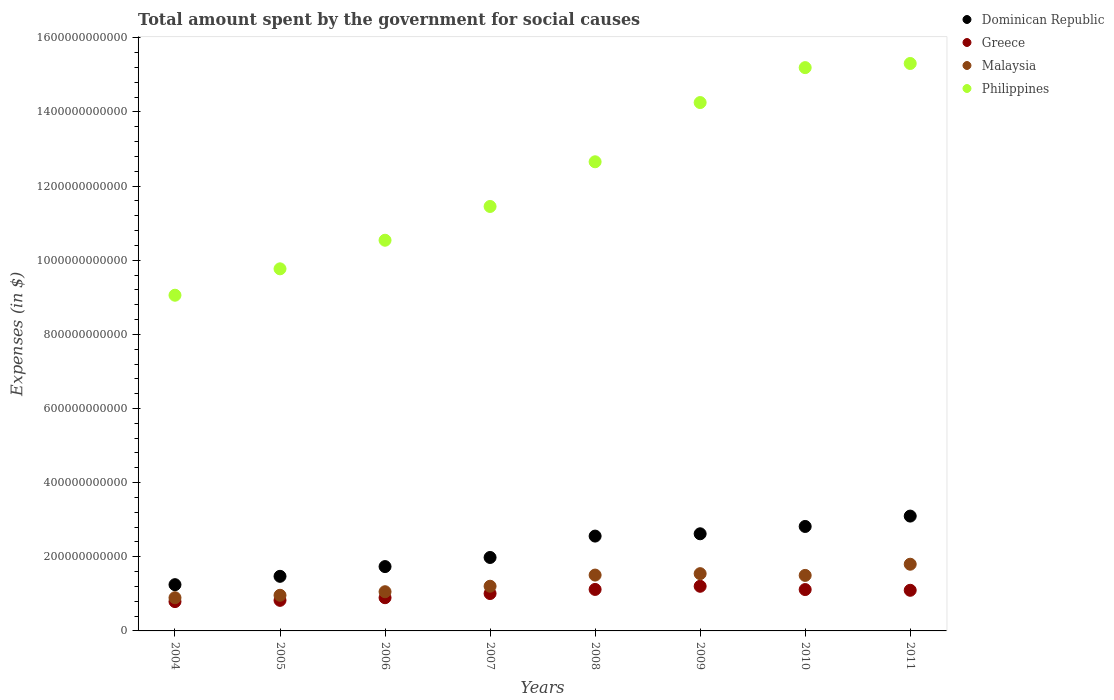How many different coloured dotlines are there?
Your answer should be very brief. 4. Is the number of dotlines equal to the number of legend labels?
Make the answer very short. Yes. What is the amount spent for social causes by the government in Greece in 2007?
Provide a succinct answer. 1.01e+11. Across all years, what is the maximum amount spent for social causes by the government in Philippines?
Keep it short and to the point. 1.53e+12. Across all years, what is the minimum amount spent for social causes by the government in Malaysia?
Keep it short and to the point. 8.95e+1. In which year was the amount spent for social causes by the government in Philippines minimum?
Offer a very short reply. 2004. What is the total amount spent for social causes by the government in Greece in the graph?
Make the answer very short. 8.06e+11. What is the difference between the amount spent for social causes by the government in Dominican Republic in 2005 and that in 2006?
Offer a very short reply. -2.63e+1. What is the difference between the amount spent for social causes by the government in Philippines in 2004 and the amount spent for social causes by the government in Greece in 2005?
Offer a terse response. 8.23e+11. What is the average amount spent for social causes by the government in Greece per year?
Offer a terse response. 1.01e+11. In the year 2010, what is the difference between the amount spent for social causes by the government in Malaysia and amount spent for social causes by the government in Dominican Republic?
Give a very brief answer. -1.32e+11. In how many years, is the amount spent for social causes by the government in Malaysia greater than 80000000000 $?
Your response must be concise. 8. What is the ratio of the amount spent for social causes by the government in Malaysia in 2004 to that in 2011?
Your answer should be compact. 0.5. Is the amount spent for social causes by the government in Malaysia in 2010 less than that in 2011?
Your answer should be compact. Yes. Is the difference between the amount spent for social causes by the government in Malaysia in 2007 and 2008 greater than the difference between the amount spent for social causes by the government in Dominican Republic in 2007 and 2008?
Your answer should be very brief. Yes. What is the difference between the highest and the second highest amount spent for social causes by the government in Greece?
Provide a short and direct response. 8.50e+09. What is the difference between the highest and the lowest amount spent for social causes by the government in Greece?
Provide a succinct answer. 4.13e+1. In how many years, is the amount spent for social causes by the government in Philippines greater than the average amount spent for social causes by the government in Philippines taken over all years?
Offer a very short reply. 4. Is the sum of the amount spent for social causes by the government in Greece in 2008 and 2011 greater than the maximum amount spent for social causes by the government in Dominican Republic across all years?
Give a very brief answer. No. Is the amount spent for social causes by the government in Dominican Republic strictly greater than the amount spent for social causes by the government in Philippines over the years?
Give a very brief answer. No. Is the amount spent for social causes by the government in Greece strictly less than the amount spent for social causes by the government in Philippines over the years?
Provide a succinct answer. Yes. What is the difference between two consecutive major ticks on the Y-axis?
Offer a terse response. 2.00e+11. Are the values on the major ticks of Y-axis written in scientific E-notation?
Give a very brief answer. No. Does the graph contain grids?
Your answer should be compact. No. How are the legend labels stacked?
Keep it short and to the point. Vertical. What is the title of the graph?
Give a very brief answer. Total amount spent by the government for social causes. Does "Montenegro" appear as one of the legend labels in the graph?
Make the answer very short. No. What is the label or title of the X-axis?
Provide a short and direct response. Years. What is the label or title of the Y-axis?
Ensure brevity in your answer.  Expenses (in $). What is the Expenses (in $) in Dominican Republic in 2004?
Your answer should be compact. 1.25e+11. What is the Expenses (in $) of Greece in 2004?
Keep it short and to the point. 7.91e+1. What is the Expenses (in $) of Malaysia in 2004?
Offer a very short reply. 8.95e+1. What is the Expenses (in $) in Philippines in 2004?
Provide a short and direct response. 9.06e+11. What is the Expenses (in $) in Dominican Republic in 2005?
Your answer should be compact. 1.47e+11. What is the Expenses (in $) of Greece in 2005?
Offer a terse response. 8.25e+1. What is the Expenses (in $) in Malaysia in 2005?
Ensure brevity in your answer.  9.61e+1. What is the Expenses (in $) in Philippines in 2005?
Make the answer very short. 9.77e+11. What is the Expenses (in $) of Dominican Republic in 2006?
Your answer should be compact. 1.74e+11. What is the Expenses (in $) of Greece in 2006?
Your answer should be very brief. 8.96e+1. What is the Expenses (in $) of Malaysia in 2006?
Provide a succinct answer. 1.06e+11. What is the Expenses (in $) in Philippines in 2006?
Your response must be concise. 1.05e+12. What is the Expenses (in $) in Dominican Republic in 2007?
Your response must be concise. 1.98e+11. What is the Expenses (in $) in Greece in 2007?
Your response must be concise. 1.01e+11. What is the Expenses (in $) of Malaysia in 2007?
Ensure brevity in your answer.  1.21e+11. What is the Expenses (in $) in Philippines in 2007?
Offer a very short reply. 1.15e+12. What is the Expenses (in $) in Dominican Republic in 2008?
Offer a very short reply. 2.56e+11. What is the Expenses (in $) of Greece in 2008?
Make the answer very short. 1.12e+11. What is the Expenses (in $) in Malaysia in 2008?
Keep it short and to the point. 1.51e+11. What is the Expenses (in $) of Philippines in 2008?
Give a very brief answer. 1.27e+12. What is the Expenses (in $) of Dominican Republic in 2009?
Make the answer very short. 2.62e+11. What is the Expenses (in $) of Greece in 2009?
Provide a succinct answer. 1.20e+11. What is the Expenses (in $) of Malaysia in 2009?
Your response must be concise. 1.54e+11. What is the Expenses (in $) in Philippines in 2009?
Ensure brevity in your answer.  1.43e+12. What is the Expenses (in $) of Dominican Republic in 2010?
Offer a terse response. 2.82e+11. What is the Expenses (in $) of Greece in 2010?
Provide a succinct answer. 1.12e+11. What is the Expenses (in $) of Malaysia in 2010?
Your answer should be very brief. 1.50e+11. What is the Expenses (in $) in Philippines in 2010?
Give a very brief answer. 1.52e+12. What is the Expenses (in $) in Dominican Republic in 2011?
Offer a terse response. 3.10e+11. What is the Expenses (in $) in Greece in 2011?
Offer a terse response. 1.10e+11. What is the Expenses (in $) of Malaysia in 2011?
Your answer should be very brief. 1.80e+11. What is the Expenses (in $) of Philippines in 2011?
Ensure brevity in your answer.  1.53e+12. Across all years, what is the maximum Expenses (in $) in Dominican Republic?
Make the answer very short. 3.10e+11. Across all years, what is the maximum Expenses (in $) in Greece?
Your answer should be very brief. 1.20e+11. Across all years, what is the maximum Expenses (in $) of Malaysia?
Keep it short and to the point. 1.80e+11. Across all years, what is the maximum Expenses (in $) in Philippines?
Your answer should be compact. 1.53e+12. Across all years, what is the minimum Expenses (in $) of Dominican Republic?
Provide a succinct answer. 1.25e+11. Across all years, what is the minimum Expenses (in $) in Greece?
Your answer should be compact. 7.91e+1. Across all years, what is the minimum Expenses (in $) of Malaysia?
Keep it short and to the point. 8.95e+1. Across all years, what is the minimum Expenses (in $) in Philippines?
Ensure brevity in your answer.  9.06e+11. What is the total Expenses (in $) in Dominican Republic in the graph?
Make the answer very short. 1.75e+12. What is the total Expenses (in $) of Greece in the graph?
Your response must be concise. 8.06e+11. What is the total Expenses (in $) of Malaysia in the graph?
Make the answer very short. 1.05e+12. What is the total Expenses (in $) of Philippines in the graph?
Give a very brief answer. 9.82e+12. What is the difference between the Expenses (in $) of Dominican Republic in 2004 and that in 2005?
Give a very brief answer. -2.25e+1. What is the difference between the Expenses (in $) of Greece in 2004 and that in 2005?
Offer a very short reply. -3.38e+09. What is the difference between the Expenses (in $) in Malaysia in 2004 and that in 2005?
Your answer should be compact. -6.61e+09. What is the difference between the Expenses (in $) of Philippines in 2004 and that in 2005?
Keep it short and to the point. -7.12e+1. What is the difference between the Expenses (in $) of Dominican Republic in 2004 and that in 2006?
Offer a terse response. -4.88e+1. What is the difference between the Expenses (in $) in Greece in 2004 and that in 2006?
Give a very brief answer. -1.05e+1. What is the difference between the Expenses (in $) in Malaysia in 2004 and that in 2006?
Make the answer very short. -1.62e+1. What is the difference between the Expenses (in $) in Philippines in 2004 and that in 2006?
Offer a terse response. -1.48e+11. What is the difference between the Expenses (in $) in Dominican Republic in 2004 and that in 2007?
Ensure brevity in your answer.  -7.34e+1. What is the difference between the Expenses (in $) in Greece in 2004 and that in 2007?
Offer a very short reply. -2.17e+1. What is the difference between the Expenses (in $) of Malaysia in 2004 and that in 2007?
Give a very brief answer. -3.10e+1. What is the difference between the Expenses (in $) in Philippines in 2004 and that in 2007?
Your answer should be compact. -2.39e+11. What is the difference between the Expenses (in $) in Dominican Republic in 2004 and that in 2008?
Ensure brevity in your answer.  -1.31e+11. What is the difference between the Expenses (in $) of Greece in 2004 and that in 2008?
Make the answer very short. -3.28e+1. What is the difference between the Expenses (in $) in Malaysia in 2004 and that in 2008?
Provide a short and direct response. -6.11e+1. What is the difference between the Expenses (in $) in Philippines in 2004 and that in 2008?
Give a very brief answer. -3.60e+11. What is the difference between the Expenses (in $) of Dominican Republic in 2004 and that in 2009?
Make the answer very short. -1.37e+11. What is the difference between the Expenses (in $) of Greece in 2004 and that in 2009?
Offer a terse response. -4.13e+1. What is the difference between the Expenses (in $) in Malaysia in 2004 and that in 2009?
Your response must be concise. -6.50e+1. What is the difference between the Expenses (in $) of Philippines in 2004 and that in 2009?
Your answer should be very brief. -5.20e+11. What is the difference between the Expenses (in $) of Dominican Republic in 2004 and that in 2010?
Provide a short and direct response. -1.57e+11. What is the difference between the Expenses (in $) of Greece in 2004 and that in 2010?
Make the answer very short. -3.25e+1. What is the difference between the Expenses (in $) in Malaysia in 2004 and that in 2010?
Keep it short and to the point. -6.02e+1. What is the difference between the Expenses (in $) in Philippines in 2004 and that in 2010?
Give a very brief answer. -6.14e+11. What is the difference between the Expenses (in $) in Dominican Republic in 2004 and that in 2011?
Your response must be concise. -1.85e+11. What is the difference between the Expenses (in $) in Greece in 2004 and that in 2011?
Keep it short and to the point. -3.05e+1. What is the difference between the Expenses (in $) in Malaysia in 2004 and that in 2011?
Your answer should be very brief. -9.04e+1. What is the difference between the Expenses (in $) of Philippines in 2004 and that in 2011?
Ensure brevity in your answer.  -6.25e+11. What is the difference between the Expenses (in $) of Dominican Republic in 2005 and that in 2006?
Provide a short and direct response. -2.63e+1. What is the difference between the Expenses (in $) of Greece in 2005 and that in 2006?
Provide a short and direct response. -7.10e+09. What is the difference between the Expenses (in $) of Malaysia in 2005 and that in 2006?
Make the answer very short. -9.60e+09. What is the difference between the Expenses (in $) of Philippines in 2005 and that in 2006?
Offer a terse response. -7.71e+1. What is the difference between the Expenses (in $) in Dominican Republic in 2005 and that in 2007?
Your response must be concise. -5.08e+1. What is the difference between the Expenses (in $) of Greece in 2005 and that in 2007?
Give a very brief answer. -1.84e+1. What is the difference between the Expenses (in $) in Malaysia in 2005 and that in 2007?
Your answer should be compact. -2.44e+1. What is the difference between the Expenses (in $) in Philippines in 2005 and that in 2007?
Your answer should be compact. -1.68e+11. What is the difference between the Expenses (in $) in Dominican Republic in 2005 and that in 2008?
Ensure brevity in your answer.  -1.09e+11. What is the difference between the Expenses (in $) in Greece in 2005 and that in 2008?
Offer a terse response. -2.95e+1. What is the difference between the Expenses (in $) in Malaysia in 2005 and that in 2008?
Offer a terse response. -5.45e+1. What is the difference between the Expenses (in $) of Philippines in 2005 and that in 2008?
Offer a very short reply. -2.89e+11. What is the difference between the Expenses (in $) of Dominican Republic in 2005 and that in 2009?
Offer a very short reply. -1.15e+11. What is the difference between the Expenses (in $) in Greece in 2005 and that in 2009?
Ensure brevity in your answer.  -3.80e+1. What is the difference between the Expenses (in $) in Malaysia in 2005 and that in 2009?
Offer a very short reply. -5.83e+1. What is the difference between the Expenses (in $) of Philippines in 2005 and that in 2009?
Provide a short and direct response. -4.49e+11. What is the difference between the Expenses (in $) in Dominican Republic in 2005 and that in 2010?
Offer a very short reply. -1.34e+11. What is the difference between the Expenses (in $) in Greece in 2005 and that in 2010?
Your response must be concise. -2.91e+1. What is the difference between the Expenses (in $) in Malaysia in 2005 and that in 2010?
Provide a succinct answer. -5.36e+1. What is the difference between the Expenses (in $) of Philippines in 2005 and that in 2010?
Your answer should be very brief. -5.43e+11. What is the difference between the Expenses (in $) of Dominican Republic in 2005 and that in 2011?
Give a very brief answer. -1.62e+11. What is the difference between the Expenses (in $) of Greece in 2005 and that in 2011?
Give a very brief answer. -2.71e+1. What is the difference between the Expenses (in $) of Malaysia in 2005 and that in 2011?
Your answer should be compact. -8.38e+1. What is the difference between the Expenses (in $) of Philippines in 2005 and that in 2011?
Offer a very short reply. -5.54e+11. What is the difference between the Expenses (in $) of Dominican Republic in 2006 and that in 2007?
Provide a short and direct response. -2.46e+1. What is the difference between the Expenses (in $) in Greece in 2006 and that in 2007?
Provide a succinct answer. -1.13e+1. What is the difference between the Expenses (in $) in Malaysia in 2006 and that in 2007?
Offer a very short reply. -1.48e+1. What is the difference between the Expenses (in $) in Philippines in 2006 and that in 2007?
Give a very brief answer. -9.11e+1. What is the difference between the Expenses (in $) in Dominican Republic in 2006 and that in 2008?
Provide a succinct answer. -8.23e+1. What is the difference between the Expenses (in $) of Greece in 2006 and that in 2008?
Provide a short and direct response. -2.24e+1. What is the difference between the Expenses (in $) of Malaysia in 2006 and that in 2008?
Your answer should be very brief. -4.49e+1. What is the difference between the Expenses (in $) in Philippines in 2006 and that in 2008?
Your response must be concise. -2.12e+11. What is the difference between the Expenses (in $) of Dominican Republic in 2006 and that in 2009?
Your answer should be very brief. -8.85e+1. What is the difference between the Expenses (in $) in Greece in 2006 and that in 2009?
Offer a terse response. -3.09e+1. What is the difference between the Expenses (in $) of Malaysia in 2006 and that in 2009?
Keep it short and to the point. -4.87e+1. What is the difference between the Expenses (in $) in Philippines in 2006 and that in 2009?
Give a very brief answer. -3.71e+11. What is the difference between the Expenses (in $) of Dominican Republic in 2006 and that in 2010?
Keep it short and to the point. -1.08e+11. What is the difference between the Expenses (in $) in Greece in 2006 and that in 2010?
Offer a very short reply. -2.20e+1. What is the difference between the Expenses (in $) of Malaysia in 2006 and that in 2010?
Give a very brief answer. -4.40e+1. What is the difference between the Expenses (in $) in Philippines in 2006 and that in 2010?
Your answer should be compact. -4.66e+11. What is the difference between the Expenses (in $) in Dominican Republic in 2006 and that in 2011?
Your answer should be very brief. -1.36e+11. What is the difference between the Expenses (in $) of Greece in 2006 and that in 2011?
Offer a terse response. -2.00e+1. What is the difference between the Expenses (in $) of Malaysia in 2006 and that in 2011?
Ensure brevity in your answer.  -7.42e+1. What is the difference between the Expenses (in $) in Philippines in 2006 and that in 2011?
Your answer should be very brief. -4.77e+11. What is the difference between the Expenses (in $) of Dominican Republic in 2007 and that in 2008?
Ensure brevity in your answer.  -5.77e+1. What is the difference between the Expenses (in $) in Greece in 2007 and that in 2008?
Keep it short and to the point. -1.11e+1. What is the difference between the Expenses (in $) in Malaysia in 2007 and that in 2008?
Offer a terse response. -3.01e+1. What is the difference between the Expenses (in $) of Philippines in 2007 and that in 2008?
Provide a succinct answer. -1.21e+11. What is the difference between the Expenses (in $) of Dominican Republic in 2007 and that in 2009?
Ensure brevity in your answer.  -6.39e+1. What is the difference between the Expenses (in $) of Greece in 2007 and that in 2009?
Your answer should be compact. -1.96e+1. What is the difference between the Expenses (in $) of Malaysia in 2007 and that in 2009?
Give a very brief answer. -3.39e+1. What is the difference between the Expenses (in $) of Philippines in 2007 and that in 2009?
Offer a very short reply. -2.80e+11. What is the difference between the Expenses (in $) in Dominican Republic in 2007 and that in 2010?
Keep it short and to the point. -8.36e+1. What is the difference between the Expenses (in $) of Greece in 2007 and that in 2010?
Your response must be concise. -1.08e+1. What is the difference between the Expenses (in $) of Malaysia in 2007 and that in 2010?
Your answer should be very brief. -2.92e+1. What is the difference between the Expenses (in $) in Philippines in 2007 and that in 2010?
Your answer should be very brief. -3.75e+11. What is the difference between the Expenses (in $) of Dominican Republic in 2007 and that in 2011?
Your response must be concise. -1.12e+11. What is the difference between the Expenses (in $) of Greece in 2007 and that in 2011?
Offer a terse response. -8.78e+09. What is the difference between the Expenses (in $) of Malaysia in 2007 and that in 2011?
Ensure brevity in your answer.  -5.94e+1. What is the difference between the Expenses (in $) in Philippines in 2007 and that in 2011?
Provide a short and direct response. -3.86e+11. What is the difference between the Expenses (in $) of Dominican Republic in 2008 and that in 2009?
Your answer should be very brief. -6.21e+09. What is the difference between the Expenses (in $) of Greece in 2008 and that in 2009?
Your answer should be compact. -8.50e+09. What is the difference between the Expenses (in $) in Malaysia in 2008 and that in 2009?
Your response must be concise. -3.82e+09. What is the difference between the Expenses (in $) in Philippines in 2008 and that in 2009?
Keep it short and to the point. -1.60e+11. What is the difference between the Expenses (in $) in Dominican Republic in 2008 and that in 2010?
Give a very brief answer. -2.60e+1. What is the difference between the Expenses (in $) in Greece in 2008 and that in 2010?
Provide a short and direct response. 3.37e+08. What is the difference between the Expenses (in $) in Malaysia in 2008 and that in 2010?
Offer a very short reply. 9.00e+08. What is the difference between the Expenses (in $) in Philippines in 2008 and that in 2010?
Your answer should be very brief. -2.54e+11. What is the difference between the Expenses (in $) in Dominican Republic in 2008 and that in 2011?
Offer a very short reply. -5.39e+1. What is the difference between the Expenses (in $) in Greece in 2008 and that in 2011?
Give a very brief answer. 2.32e+09. What is the difference between the Expenses (in $) in Malaysia in 2008 and that in 2011?
Keep it short and to the point. -2.93e+1. What is the difference between the Expenses (in $) of Philippines in 2008 and that in 2011?
Your answer should be very brief. -2.65e+11. What is the difference between the Expenses (in $) of Dominican Republic in 2009 and that in 2010?
Your response must be concise. -1.97e+1. What is the difference between the Expenses (in $) of Greece in 2009 and that in 2010?
Provide a succinct answer. 8.84e+09. What is the difference between the Expenses (in $) in Malaysia in 2009 and that in 2010?
Your answer should be compact. 4.72e+09. What is the difference between the Expenses (in $) in Philippines in 2009 and that in 2010?
Provide a succinct answer. -9.42e+1. What is the difference between the Expenses (in $) in Dominican Republic in 2009 and that in 2011?
Ensure brevity in your answer.  -4.77e+1. What is the difference between the Expenses (in $) of Greece in 2009 and that in 2011?
Your answer should be compact. 1.08e+1. What is the difference between the Expenses (in $) of Malaysia in 2009 and that in 2011?
Provide a succinct answer. -2.54e+1. What is the difference between the Expenses (in $) of Philippines in 2009 and that in 2011?
Your answer should be very brief. -1.05e+11. What is the difference between the Expenses (in $) of Dominican Republic in 2010 and that in 2011?
Your response must be concise. -2.80e+1. What is the difference between the Expenses (in $) in Greece in 2010 and that in 2011?
Offer a terse response. 1.98e+09. What is the difference between the Expenses (in $) of Malaysia in 2010 and that in 2011?
Make the answer very short. -3.02e+1. What is the difference between the Expenses (in $) of Philippines in 2010 and that in 2011?
Your answer should be very brief. -1.12e+1. What is the difference between the Expenses (in $) of Dominican Republic in 2004 and the Expenses (in $) of Greece in 2005?
Your response must be concise. 4.23e+1. What is the difference between the Expenses (in $) of Dominican Republic in 2004 and the Expenses (in $) of Malaysia in 2005?
Ensure brevity in your answer.  2.86e+1. What is the difference between the Expenses (in $) in Dominican Republic in 2004 and the Expenses (in $) in Philippines in 2005?
Provide a succinct answer. -8.52e+11. What is the difference between the Expenses (in $) of Greece in 2004 and the Expenses (in $) of Malaysia in 2005?
Ensure brevity in your answer.  -1.70e+1. What is the difference between the Expenses (in $) of Greece in 2004 and the Expenses (in $) of Philippines in 2005?
Your response must be concise. -8.98e+11. What is the difference between the Expenses (in $) in Malaysia in 2004 and the Expenses (in $) in Philippines in 2005?
Your answer should be compact. -8.87e+11. What is the difference between the Expenses (in $) in Dominican Republic in 2004 and the Expenses (in $) in Greece in 2006?
Your response must be concise. 3.52e+1. What is the difference between the Expenses (in $) of Dominican Republic in 2004 and the Expenses (in $) of Malaysia in 2006?
Provide a short and direct response. 1.90e+1. What is the difference between the Expenses (in $) in Dominican Republic in 2004 and the Expenses (in $) in Philippines in 2006?
Your answer should be compact. -9.29e+11. What is the difference between the Expenses (in $) of Greece in 2004 and the Expenses (in $) of Malaysia in 2006?
Offer a terse response. -2.67e+1. What is the difference between the Expenses (in $) in Greece in 2004 and the Expenses (in $) in Philippines in 2006?
Offer a terse response. -9.75e+11. What is the difference between the Expenses (in $) in Malaysia in 2004 and the Expenses (in $) in Philippines in 2006?
Your response must be concise. -9.64e+11. What is the difference between the Expenses (in $) in Dominican Republic in 2004 and the Expenses (in $) in Greece in 2007?
Give a very brief answer. 2.39e+1. What is the difference between the Expenses (in $) in Dominican Republic in 2004 and the Expenses (in $) in Malaysia in 2007?
Your response must be concise. 4.23e+09. What is the difference between the Expenses (in $) in Dominican Republic in 2004 and the Expenses (in $) in Philippines in 2007?
Your answer should be very brief. -1.02e+12. What is the difference between the Expenses (in $) in Greece in 2004 and the Expenses (in $) in Malaysia in 2007?
Offer a very short reply. -4.15e+1. What is the difference between the Expenses (in $) of Greece in 2004 and the Expenses (in $) of Philippines in 2007?
Give a very brief answer. -1.07e+12. What is the difference between the Expenses (in $) of Malaysia in 2004 and the Expenses (in $) of Philippines in 2007?
Your response must be concise. -1.06e+12. What is the difference between the Expenses (in $) of Dominican Republic in 2004 and the Expenses (in $) of Greece in 2008?
Offer a very short reply. 1.29e+1. What is the difference between the Expenses (in $) in Dominican Republic in 2004 and the Expenses (in $) in Malaysia in 2008?
Provide a short and direct response. -2.59e+1. What is the difference between the Expenses (in $) of Dominican Republic in 2004 and the Expenses (in $) of Philippines in 2008?
Your response must be concise. -1.14e+12. What is the difference between the Expenses (in $) of Greece in 2004 and the Expenses (in $) of Malaysia in 2008?
Your answer should be compact. -7.16e+1. What is the difference between the Expenses (in $) of Greece in 2004 and the Expenses (in $) of Philippines in 2008?
Your response must be concise. -1.19e+12. What is the difference between the Expenses (in $) of Malaysia in 2004 and the Expenses (in $) of Philippines in 2008?
Give a very brief answer. -1.18e+12. What is the difference between the Expenses (in $) of Dominican Republic in 2004 and the Expenses (in $) of Greece in 2009?
Your answer should be very brief. 4.35e+09. What is the difference between the Expenses (in $) of Dominican Republic in 2004 and the Expenses (in $) of Malaysia in 2009?
Give a very brief answer. -2.97e+1. What is the difference between the Expenses (in $) in Dominican Republic in 2004 and the Expenses (in $) in Philippines in 2009?
Provide a succinct answer. -1.30e+12. What is the difference between the Expenses (in $) in Greece in 2004 and the Expenses (in $) in Malaysia in 2009?
Your answer should be very brief. -7.54e+1. What is the difference between the Expenses (in $) of Greece in 2004 and the Expenses (in $) of Philippines in 2009?
Give a very brief answer. -1.35e+12. What is the difference between the Expenses (in $) in Malaysia in 2004 and the Expenses (in $) in Philippines in 2009?
Ensure brevity in your answer.  -1.34e+12. What is the difference between the Expenses (in $) of Dominican Republic in 2004 and the Expenses (in $) of Greece in 2010?
Offer a terse response. 1.32e+1. What is the difference between the Expenses (in $) in Dominican Republic in 2004 and the Expenses (in $) in Malaysia in 2010?
Offer a very short reply. -2.50e+1. What is the difference between the Expenses (in $) of Dominican Republic in 2004 and the Expenses (in $) of Philippines in 2010?
Make the answer very short. -1.39e+12. What is the difference between the Expenses (in $) of Greece in 2004 and the Expenses (in $) of Malaysia in 2010?
Ensure brevity in your answer.  -7.07e+1. What is the difference between the Expenses (in $) of Greece in 2004 and the Expenses (in $) of Philippines in 2010?
Give a very brief answer. -1.44e+12. What is the difference between the Expenses (in $) in Malaysia in 2004 and the Expenses (in $) in Philippines in 2010?
Make the answer very short. -1.43e+12. What is the difference between the Expenses (in $) of Dominican Republic in 2004 and the Expenses (in $) of Greece in 2011?
Ensure brevity in your answer.  1.52e+1. What is the difference between the Expenses (in $) of Dominican Republic in 2004 and the Expenses (in $) of Malaysia in 2011?
Your answer should be compact. -5.51e+1. What is the difference between the Expenses (in $) of Dominican Republic in 2004 and the Expenses (in $) of Philippines in 2011?
Give a very brief answer. -1.41e+12. What is the difference between the Expenses (in $) of Greece in 2004 and the Expenses (in $) of Malaysia in 2011?
Offer a terse response. -1.01e+11. What is the difference between the Expenses (in $) of Greece in 2004 and the Expenses (in $) of Philippines in 2011?
Ensure brevity in your answer.  -1.45e+12. What is the difference between the Expenses (in $) in Malaysia in 2004 and the Expenses (in $) in Philippines in 2011?
Offer a very short reply. -1.44e+12. What is the difference between the Expenses (in $) of Dominican Republic in 2005 and the Expenses (in $) of Greece in 2006?
Your answer should be very brief. 5.77e+1. What is the difference between the Expenses (in $) of Dominican Republic in 2005 and the Expenses (in $) of Malaysia in 2006?
Make the answer very short. 4.16e+1. What is the difference between the Expenses (in $) of Dominican Republic in 2005 and the Expenses (in $) of Philippines in 2006?
Provide a short and direct response. -9.07e+11. What is the difference between the Expenses (in $) in Greece in 2005 and the Expenses (in $) in Malaysia in 2006?
Your answer should be compact. -2.33e+1. What is the difference between the Expenses (in $) of Greece in 2005 and the Expenses (in $) of Philippines in 2006?
Ensure brevity in your answer.  -9.71e+11. What is the difference between the Expenses (in $) in Malaysia in 2005 and the Expenses (in $) in Philippines in 2006?
Offer a terse response. -9.58e+11. What is the difference between the Expenses (in $) of Dominican Republic in 2005 and the Expenses (in $) of Greece in 2007?
Your answer should be very brief. 4.65e+1. What is the difference between the Expenses (in $) in Dominican Republic in 2005 and the Expenses (in $) in Malaysia in 2007?
Make the answer very short. 2.67e+1. What is the difference between the Expenses (in $) in Dominican Republic in 2005 and the Expenses (in $) in Philippines in 2007?
Give a very brief answer. -9.98e+11. What is the difference between the Expenses (in $) of Greece in 2005 and the Expenses (in $) of Malaysia in 2007?
Ensure brevity in your answer.  -3.81e+1. What is the difference between the Expenses (in $) of Greece in 2005 and the Expenses (in $) of Philippines in 2007?
Your answer should be very brief. -1.06e+12. What is the difference between the Expenses (in $) of Malaysia in 2005 and the Expenses (in $) of Philippines in 2007?
Ensure brevity in your answer.  -1.05e+12. What is the difference between the Expenses (in $) of Dominican Republic in 2005 and the Expenses (in $) of Greece in 2008?
Ensure brevity in your answer.  3.54e+1. What is the difference between the Expenses (in $) in Dominican Republic in 2005 and the Expenses (in $) in Malaysia in 2008?
Provide a short and direct response. -3.37e+09. What is the difference between the Expenses (in $) in Dominican Republic in 2005 and the Expenses (in $) in Philippines in 2008?
Provide a succinct answer. -1.12e+12. What is the difference between the Expenses (in $) of Greece in 2005 and the Expenses (in $) of Malaysia in 2008?
Keep it short and to the point. -6.82e+1. What is the difference between the Expenses (in $) of Greece in 2005 and the Expenses (in $) of Philippines in 2008?
Offer a terse response. -1.18e+12. What is the difference between the Expenses (in $) in Malaysia in 2005 and the Expenses (in $) in Philippines in 2008?
Offer a terse response. -1.17e+12. What is the difference between the Expenses (in $) of Dominican Republic in 2005 and the Expenses (in $) of Greece in 2009?
Keep it short and to the point. 2.69e+1. What is the difference between the Expenses (in $) of Dominican Republic in 2005 and the Expenses (in $) of Malaysia in 2009?
Offer a terse response. -7.19e+09. What is the difference between the Expenses (in $) of Dominican Republic in 2005 and the Expenses (in $) of Philippines in 2009?
Your answer should be compact. -1.28e+12. What is the difference between the Expenses (in $) in Greece in 2005 and the Expenses (in $) in Malaysia in 2009?
Offer a terse response. -7.20e+1. What is the difference between the Expenses (in $) in Greece in 2005 and the Expenses (in $) in Philippines in 2009?
Provide a short and direct response. -1.34e+12. What is the difference between the Expenses (in $) of Malaysia in 2005 and the Expenses (in $) of Philippines in 2009?
Ensure brevity in your answer.  -1.33e+12. What is the difference between the Expenses (in $) in Dominican Republic in 2005 and the Expenses (in $) in Greece in 2010?
Your answer should be very brief. 3.57e+1. What is the difference between the Expenses (in $) in Dominican Republic in 2005 and the Expenses (in $) in Malaysia in 2010?
Your response must be concise. -2.46e+09. What is the difference between the Expenses (in $) of Dominican Republic in 2005 and the Expenses (in $) of Philippines in 2010?
Your answer should be very brief. -1.37e+12. What is the difference between the Expenses (in $) of Greece in 2005 and the Expenses (in $) of Malaysia in 2010?
Ensure brevity in your answer.  -6.73e+1. What is the difference between the Expenses (in $) in Greece in 2005 and the Expenses (in $) in Philippines in 2010?
Offer a terse response. -1.44e+12. What is the difference between the Expenses (in $) of Malaysia in 2005 and the Expenses (in $) of Philippines in 2010?
Provide a succinct answer. -1.42e+12. What is the difference between the Expenses (in $) in Dominican Republic in 2005 and the Expenses (in $) in Greece in 2011?
Keep it short and to the point. 3.77e+1. What is the difference between the Expenses (in $) of Dominican Republic in 2005 and the Expenses (in $) of Malaysia in 2011?
Provide a short and direct response. -3.26e+1. What is the difference between the Expenses (in $) in Dominican Republic in 2005 and the Expenses (in $) in Philippines in 2011?
Your response must be concise. -1.38e+12. What is the difference between the Expenses (in $) of Greece in 2005 and the Expenses (in $) of Malaysia in 2011?
Your response must be concise. -9.75e+1. What is the difference between the Expenses (in $) in Greece in 2005 and the Expenses (in $) in Philippines in 2011?
Make the answer very short. -1.45e+12. What is the difference between the Expenses (in $) of Malaysia in 2005 and the Expenses (in $) of Philippines in 2011?
Ensure brevity in your answer.  -1.43e+12. What is the difference between the Expenses (in $) of Dominican Republic in 2006 and the Expenses (in $) of Greece in 2007?
Your response must be concise. 7.27e+1. What is the difference between the Expenses (in $) in Dominican Republic in 2006 and the Expenses (in $) in Malaysia in 2007?
Keep it short and to the point. 5.30e+1. What is the difference between the Expenses (in $) of Dominican Republic in 2006 and the Expenses (in $) of Philippines in 2007?
Ensure brevity in your answer.  -9.71e+11. What is the difference between the Expenses (in $) of Greece in 2006 and the Expenses (in $) of Malaysia in 2007?
Provide a short and direct response. -3.10e+1. What is the difference between the Expenses (in $) of Greece in 2006 and the Expenses (in $) of Philippines in 2007?
Make the answer very short. -1.06e+12. What is the difference between the Expenses (in $) of Malaysia in 2006 and the Expenses (in $) of Philippines in 2007?
Offer a very short reply. -1.04e+12. What is the difference between the Expenses (in $) of Dominican Republic in 2006 and the Expenses (in $) of Greece in 2008?
Keep it short and to the point. 6.16e+1. What is the difference between the Expenses (in $) of Dominican Republic in 2006 and the Expenses (in $) of Malaysia in 2008?
Your response must be concise. 2.29e+1. What is the difference between the Expenses (in $) in Dominican Republic in 2006 and the Expenses (in $) in Philippines in 2008?
Your answer should be compact. -1.09e+12. What is the difference between the Expenses (in $) of Greece in 2006 and the Expenses (in $) of Malaysia in 2008?
Ensure brevity in your answer.  -6.11e+1. What is the difference between the Expenses (in $) in Greece in 2006 and the Expenses (in $) in Philippines in 2008?
Offer a terse response. -1.18e+12. What is the difference between the Expenses (in $) in Malaysia in 2006 and the Expenses (in $) in Philippines in 2008?
Your response must be concise. -1.16e+12. What is the difference between the Expenses (in $) of Dominican Republic in 2006 and the Expenses (in $) of Greece in 2009?
Keep it short and to the point. 5.31e+1. What is the difference between the Expenses (in $) of Dominican Republic in 2006 and the Expenses (in $) of Malaysia in 2009?
Offer a terse response. 1.91e+1. What is the difference between the Expenses (in $) of Dominican Republic in 2006 and the Expenses (in $) of Philippines in 2009?
Offer a terse response. -1.25e+12. What is the difference between the Expenses (in $) of Greece in 2006 and the Expenses (in $) of Malaysia in 2009?
Ensure brevity in your answer.  -6.49e+1. What is the difference between the Expenses (in $) in Greece in 2006 and the Expenses (in $) in Philippines in 2009?
Provide a succinct answer. -1.34e+12. What is the difference between the Expenses (in $) of Malaysia in 2006 and the Expenses (in $) of Philippines in 2009?
Make the answer very short. -1.32e+12. What is the difference between the Expenses (in $) in Dominican Republic in 2006 and the Expenses (in $) in Greece in 2010?
Your answer should be very brief. 6.20e+1. What is the difference between the Expenses (in $) in Dominican Republic in 2006 and the Expenses (in $) in Malaysia in 2010?
Your answer should be very brief. 2.38e+1. What is the difference between the Expenses (in $) in Dominican Republic in 2006 and the Expenses (in $) in Philippines in 2010?
Provide a short and direct response. -1.35e+12. What is the difference between the Expenses (in $) in Greece in 2006 and the Expenses (in $) in Malaysia in 2010?
Keep it short and to the point. -6.02e+1. What is the difference between the Expenses (in $) of Greece in 2006 and the Expenses (in $) of Philippines in 2010?
Keep it short and to the point. -1.43e+12. What is the difference between the Expenses (in $) of Malaysia in 2006 and the Expenses (in $) of Philippines in 2010?
Make the answer very short. -1.41e+12. What is the difference between the Expenses (in $) in Dominican Republic in 2006 and the Expenses (in $) in Greece in 2011?
Your answer should be very brief. 6.40e+1. What is the difference between the Expenses (in $) in Dominican Republic in 2006 and the Expenses (in $) in Malaysia in 2011?
Ensure brevity in your answer.  -6.36e+09. What is the difference between the Expenses (in $) of Dominican Republic in 2006 and the Expenses (in $) of Philippines in 2011?
Make the answer very short. -1.36e+12. What is the difference between the Expenses (in $) of Greece in 2006 and the Expenses (in $) of Malaysia in 2011?
Your answer should be compact. -9.04e+1. What is the difference between the Expenses (in $) of Greece in 2006 and the Expenses (in $) of Philippines in 2011?
Provide a succinct answer. -1.44e+12. What is the difference between the Expenses (in $) in Malaysia in 2006 and the Expenses (in $) in Philippines in 2011?
Provide a succinct answer. -1.43e+12. What is the difference between the Expenses (in $) of Dominican Republic in 2007 and the Expenses (in $) of Greece in 2008?
Offer a very short reply. 8.62e+1. What is the difference between the Expenses (in $) in Dominican Republic in 2007 and the Expenses (in $) in Malaysia in 2008?
Your answer should be very brief. 4.75e+1. What is the difference between the Expenses (in $) of Dominican Republic in 2007 and the Expenses (in $) of Philippines in 2008?
Keep it short and to the point. -1.07e+12. What is the difference between the Expenses (in $) of Greece in 2007 and the Expenses (in $) of Malaysia in 2008?
Make the answer very short. -4.98e+1. What is the difference between the Expenses (in $) in Greece in 2007 and the Expenses (in $) in Philippines in 2008?
Offer a terse response. -1.16e+12. What is the difference between the Expenses (in $) in Malaysia in 2007 and the Expenses (in $) in Philippines in 2008?
Your answer should be very brief. -1.15e+12. What is the difference between the Expenses (in $) in Dominican Republic in 2007 and the Expenses (in $) in Greece in 2009?
Offer a very short reply. 7.77e+1. What is the difference between the Expenses (in $) in Dominican Republic in 2007 and the Expenses (in $) in Malaysia in 2009?
Offer a terse response. 4.37e+1. What is the difference between the Expenses (in $) in Dominican Republic in 2007 and the Expenses (in $) in Philippines in 2009?
Give a very brief answer. -1.23e+12. What is the difference between the Expenses (in $) in Greece in 2007 and the Expenses (in $) in Malaysia in 2009?
Make the answer very short. -5.37e+1. What is the difference between the Expenses (in $) of Greece in 2007 and the Expenses (in $) of Philippines in 2009?
Make the answer very short. -1.32e+12. What is the difference between the Expenses (in $) in Malaysia in 2007 and the Expenses (in $) in Philippines in 2009?
Your response must be concise. -1.30e+12. What is the difference between the Expenses (in $) in Dominican Republic in 2007 and the Expenses (in $) in Greece in 2010?
Your answer should be very brief. 8.65e+1. What is the difference between the Expenses (in $) of Dominican Republic in 2007 and the Expenses (in $) of Malaysia in 2010?
Your answer should be very brief. 4.84e+1. What is the difference between the Expenses (in $) in Dominican Republic in 2007 and the Expenses (in $) in Philippines in 2010?
Your answer should be very brief. -1.32e+12. What is the difference between the Expenses (in $) of Greece in 2007 and the Expenses (in $) of Malaysia in 2010?
Offer a terse response. -4.89e+1. What is the difference between the Expenses (in $) in Greece in 2007 and the Expenses (in $) in Philippines in 2010?
Your answer should be very brief. -1.42e+12. What is the difference between the Expenses (in $) of Malaysia in 2007 and the Expenses (in $) of Philippines in 2010?
Your answer should be compact. -1.40e+12. What is the difference between the Expenses (in $) in Dominican Republic in 2007 and the Expenses (in $) in Greece in 2011?
Your answer should be very brief. 8.85e+1. What is the difference between the Expenses (in $) of Dominican Republic in 2007 and the Expenses (in $) of Malaysia in 2011?
Provide a short and direct response. 1.82e+1. What is the difference between the Expenses (in $) of Dominican Republic in 2007 and the Expenses (in $) of Philippines in 2011?
Provide a succinct answer. -1.33e+12. What is the difference between the Expenses (in $) of Greece in 2007 and the Expenses (in $) of Malaysia in 2011?
Provide a short and direct response. -7.91e+1. What is the difference between the Expenses (in $) of Greece in 2007 and the Expenses (in $) of Philippines in 2011?
Offer a terse response. -1.43e+12. What is the difference between the Expenses (in $) in Malaysia in 2007 and the Expenses (in $) in Philippines in 2011?
Keep it short and to the point. -1.41e+12. What is the difference between the Expenses (in $) in Dominican Republic in 2008 and the Expenses (in $) in Greece in 2009?
Keep it short and to the point. 1.35e+11. What is the difference between the Expenses (in $) in Dominican Republic in 2008 and the Expenses (in $) in Malaysia in 2009?
Your response must be concise. 1.01e+11. What is the difference between the Expenses (in $) of Dominican Republic in 2008 and the Expenses (in $) of Philippines in 2009?
Offer a terse response. -1.17e+12. What is the difference between the Expenses (in $) of Greece in 2008 and the Expenses (in $) of Malaysia in 2009?
Your answer should be compact. -4.26e+1. What is the difference between the Expenses (in $) in Greece in 2008 and the Expenses (in $) in Philippines in 2009?
Give a very brief answer. -1.31e+12. What is the difference between the Expenses (in $) of Malaysia in 2008 and the Expenses (in $) of Philippines in 2009?
Your answer should be very brief. -1.27e+12. What is the difference between the Expenses (in $) of Dominican Republic in 2008 and the Expenses (in $) of Greece in 2010?
Offer a very short reply. 1.44e+11. What is the difference between the Expenses (in $) of Dominican Republic in 2008 and the Expenses (in $) of Malaysia in 2010?
Your answer should be very brief. 1.06e+11. What is the difference between the Expenses (in $) of Dominican Republic in 2008 and the Expenses (in $) of Philippines in 2010?
Offer a terse response. -1.26e+12. What is the difference between the Expenses (in $) in Greece in 2008 and the Expenses (in $) in Malaysia in 2010?
Ensure brevity in your answer.  -3.78e+1. What is the difference between the Expenses (in $) in Greece in 2008 and the Expenses (in $) in Philippines in 2010?
Provide a succinct answer. -1.41e+12. What is the difference between the Expenses (in $) of Malaysia in 2008 and the Expenses (in $) of Philippines in 2010?
Your response must be concise. -1.37e+12. What is the difference between the Expenses (in $) of Dominican Republic in 2008 and the Expenses (in $) of Greece in 2011?
Offer a terse response. 1.46e+11. What is the difference between the Expenses (in $) of Dominican Republic in 2008 and the Expenses (in $) of Malaysia in 2011?
Offer a very short reply. 7.59e+1. What is the difference between the Expenses (in $) in Dominican Republic in 2008 and the Expenses (in $) in Philippines in 2011?
Your response must be concise. -1.27e+12. What is the difference between the Expenses (in $) of Greece in 2008 and the Expenses (in $) of Malaysia in 2011?
Give a very brief answer. -6.80e+1. What is the difference between the Expenses (in $) of Greece in 2008 and the Expenses (in $) of Philippines in 2011?
Your response must be concise. -1.42e+12. What is the difference between the Expenses (in $) of Malaysia in 2008 and the Expenses (in $) of Philippines in 2011?
Keep it short and to the point. -1.38e+12. What is the difference between the Expenses (in $) of Dominican Republic in 2009 and the Expenses (in $) of Greece in 2010?
Give a very brief answer. 1.50e+11. What is the difference between the Expenses (in $) of Dominican Republic in 2009 and the Expenses (in $) of Malaysia in 2010?
Offer a very short reply. 1.12e+11. What is the difference between the Expenses (in $) of Dominican Republic in 2009 and the Expenses (in $) of Philippines in 2010?
Your answer should be very brief. -1.26e+12. What is the difference between the Expenses (in $) in Greece in 2009 and the Expenses (in $) in Malaysia in 2010?
Your response must be concise. -2.93e+1. What is the difference between the Expenses (in $) of Greece in 2009 and the Expenses (in $) of Philippines in 2010?
Offer a terse response. -1.40e+12. What is the difference between the Expenses (in $) of Malaysia in 2009 and the Expenses (in $) of Philippines in 2010?
Your answer should be compact. -1.37e+12. What is the difference between the Expenses (in $) of Dominican Republic in 2009 and the Expenses (in $) of Greece in 2011?
Provide a succinct answer. 1.52e+11. What is the difference between the Expenses (in $) of Dominican Republic in 2009 and the Expenses (in $) of Malaysia in 2011?
Ensure brevity in your answer.  8.21e+1. What is the difference between the Expenses (in $) in Dominican Republic in 2009 and the Expenses (in $) in Philippines in 2011?
Provide a succinct answer. -1.27e+12. What is the difference between the Expenses (in $) of Greece in 2009 and the Expenses (in $) of Malaysia in 2011?
Offer a terse response. -5.95e+1. What is the difference between the Expenses (in $) in Greece in 2009 and the Expenses (in $) in Philippines in 2011?
Ensure brevity in your answer.  -1.41e+12. What is the difference between the Expenses (in $) of Malaysia in 2009 and the Expenses (in $) of Philippines in 2011?
Provide a succinct answer. -1.38e+12. What is the difference between the Expenses (in $) of Dominican Republic in 2010 and the Expenses (in $) of Greece in 2011?
Keep it short and to the point. 1.72e+11. What is the difference between the Expenses (in $) of Dominican Republic in 2010 and the Expenses (in $) of Malaysia in 2011?
Offer a terse response. 1.02e+11. What is the difference between the Expenses (in $) of Dominican Republic in 2010 and the Expenses (in $) of Philippines in 2011?
Keep it short and to the point. -1.25e+12. What is the difference between the Expenses (in $) of Greece in 2010 and the Expenses (in $) of Malaysia in 2011?
Your answer should be very brief. -6.83e+1. What is the difference between the Expenses (in $) of Greece in 2010 and the Expenses (in $) of Philippines in 2011?
Your answer should be compact. -1.42e+12. What is the difference between the Expenses (in $) in Malaysia in 2010 and the Expenses (in $) in Philippines in 2011?
Your response must be concise. -1.38e+12. What is the average Expenses (in $) in Dominican Republic per year?
Keep it short and to the point. 2.19e+11. What is the average Expenses (in $) in Greece per year?
Your answer should be compact. 1.01e+11. What is the average Expenses (in $) in Malaysia per year?
Offer a very short reply. 1.31e+11. What is the average Expenses (in $) in Philippines per year?
Offer a very short reply. 1.23e+12. In the year 2004, what is the difference between the Expenses (in $) in Dominican Republic and Expenses (in $) in Greece?
Your response must be concise. 4.57e+1. In the year 2004, what is the difference between the Expenses (in $) of Dominican Republic and Expenses (in $) of Malaysia?
Your answer should be very brief. 3.52e+1. In the year 2004, what is the difference between the Expenses (in $) of Dominican Republic and Expenses (in $) of Philippines?
Your response must be concise. -7.81e+11. In the year 2004, what is the difference between the Expenses (in $) of Greece and Expenses (in $) of Malaysia?
Your response must be concise. -1.04e+1. In the year 2004, what is the difference between the Expenses (in $) in Greece and Expenses (in $) in Philippines?
Offer a terse response. -8.26e+11. In the year 2004, what is the difference between the Expenses (in $) in Malaysia and Expenses (in $) in Philippines?
Your response must be concise. -8.16e+11. In the year 2005, what is the difference between the Expenses (in $) in Dominican Republic and Expenses (in $) in Greece?
Keep it short and to the point. 6.48e+1. In the year 2005, what is the difference between the Expenses (in $) of Dominican Republic and Expenses (in $) of Malaysia?
Your answer should be very brief. 5.12e+1. In the year 2005, what is the difference between the Expenses (in $) of Dominican Republic and Expenses (in $) of Philippines?
Provide a succinct answer. -8.30e+11. In the year 2005, what is the difference between the Expenses (in $) of Greece and Expenses (in $) of Malaysia?
Give a very brief answer. -1.37e+1. In the year 2005, what is the difference between the Expenses (in $) of Greece and Expenses (in $) of Philippines?
Your answer should be very brief. -8.94e+11. In the year 2005, what is the difference between the Expenses (in $) of Malaysia and Expenses (in $) of Philippines?
Your answer should be very brief. -8.81e+11. In the year 2006, what is the difference between the Expenses (in $) in Dominican Republic and Expenses (in $) in Greece?
Provide a succinct answer. 8.40e+1. In the year 2006, what is the difference between the Expenses (in $) of Dominican Republic and Expenses (in $) of Malaysia?
Provide a short and direct response. 6.78e+1. In the year 2006, what is the difference between the Expenses (in $) in Dominican Republic and Expenses (in $) in Philippines?
Your response must be concise. -8.80e+11. In the year 2006, what is the difference between the Expenses (in $) in Greece and Expenses (in $) in Malaysia?
Your response must be concise. -1.62e+1. In the year 2006, what is the difference between the Expenses (in $) of Greece and Expenses (in $) of Philippines?
Offer a terse response. -9.64e+11. In the year 2006, what is the difference between the Expenses (in $) of Malaysia and Expenses (in $) of Philippines?
Offer a very short reply. -9.48e+11. In the year 2007, what is the difference between the Expenses (in $) of Dominican Republic and Expenses (in $) of Greece?
Offer a terse response. 9.73e+1. In the year 2007, what is the difference between the Expenses (in $) of Dominican Republic and Expenses (in $) of Malaysia?
Ensure brevity in your answer.  7.76e+1. In the year 2007, what is the difference between the Expenses (in $) in Dominican Republic and Expenses (in $) in Philippines?
Give a very brief answer. -9.47e+11. In the year 2007, what is the difference between the Expenses (in $) in Greece and Expenses (in $) in Malaysia?
Offer a very short reply. -1.97e+1. In the year 2007, what is the difference between the Expenses (in $) of Greece and Expenses (in $) of Philippines?
Your answer should be very brief. -1.04e+12. In the year 2007, what is the difference between the Expenses (in $) of Malaysia and Expenses (in $) of Philippines?
Give a very brief answer. -1.02e+12. In the year 2008, what is the difference between the Expenses (in $) of Dominican Republic and Expenses (in $) of Greece?
Make the answer very short. 1.44e+11. In the year 2008, what is the difference between the Expenses (in $) in Dominican Republic and Expenses (in $) in Malaysia?
Provide a short and direct response. 1.05e+11. In the year 2008, what is the difference between the Expenses (in $) of Dominican Republic and Expenses (in $) of Philippines?
Offer a very short reply. -1.01e+12. In the year 2008, what is the difference between the Expenses (in $) of Greece and Expenses (in $) of Malaysia?
Offer a very short reply. -3.87e+1. In the year 2008, what is the difference between the Expenses (in $) of Greece and Expenses (in $) of Philippines?
Ensure brevity in your answer.  -1.15e+12. In the year 2008, what is the difference between the Expenses (in $) of Malaysia and Expenses (in $) of Philippines?
Ensure brevity in your answer.  -1.11e+12. In the year 2009, what is the difference between the Expenses (in $) in Dominican Republic and Expenses (in $) in Greece?
Provide a short and direct response. 1.42e+11. In the year 2009, what is the difference between the Expenses (in $) of Dominican Republic and Expenses (in $) of Malaysia?
Offer a terse response. 1.08e+11. In the year 2009, what is the difference between the Expenses (in $) in Dominican Republic and Expenses (in $) in Philippines?
Make the answer very short. -1.16e+12. In the year 2009, what is the difference between the Expenses (in $) of Greece and Expenses (in $) of Malaysia?
Make the answer very short. -3.40e+1. In the year 2009, what is the difference between the Expenses (in $) in Greece and Expenses (in $) in Philippines?
Your answer should be compact. -1.30e+12. In the year 2009, what is the difference between the Expenses (in $) of Malaysia and Expenses (in $) of Philippines?
Provide a succinct answer. -1.27e+12. In the year 2010, what is the difference between the Expenses (in $) of Dominican Republic and Expenses (in $) of Greece?
Your answer should be compact. 1.70e+11. In the year 2010, what is the difference between the Expenses (in $) in Dominican Republic and Expenses (in $) in Malaysia?
Your answer should be very brief. 1.32e+11. In the year 2010, what is the difference between the Expenses (in $) of Dominican Republic and Expenses (in $) of Philippines?
Offer a very short reply. -1.24e+12. In the year 2010, what is the difference between the Expenses (in $) of Greece and Expenses (in $) of Malaysia?
Your answer should be compact. -3.82e+1. In the year 2010, what is the difference between the Expenses (in $) of Greece and Expenses (in $) of Philippines?
Make the answer very short. -1.41e+12. In the year 2010, what is the difference between the Expenses (in $) of Malaysia and Expenses (in $) of Philippines?
Your answer should be compact. -1.37e+12. In the year 2011, what is the difference between the Expenses (in $) of Dominican Republic and Expenses (in $) of Greece?
Make the answer very short. 2.00e+11. In the year 2011, what is the difference between the Expenses (in $) in Dominican Republic and Expenses (in $) in Malaysia?
Your answer should be very brief. 1.30e+11. In the year 2011, what is the difference between the Expenses (in $) in Dominican Republic and Expenses (in $) in Philippines?
Keep it short and to the point. -1.22e+12. In the year 2011, what is the difference between the Expenses (in $) in Greece and Expenses (in $) in Malaysia?
Your answer should be very brief. -7.03e+1. In the year 2011, what is the difference between the Expenses (in $) in Greece and Expenses (in $) in Philippines?
Make the answer very short. -1.42e+12. In the year 2011, what is the difference between the Expenses (in $) in Malaysia and Expenses (in $) in Philippines?
Ensure brevity in your answer.  -1.35e+12. What is the ratio of the Expenses (in $) of Dominican Republic in 2004 to that in 2005?
Keep it short and to the point. 0.85. What is the ratio of the Expenses (in $) of Greece in 2004 to that in 2005?
Your answer should be compact. 0.96. What is the ratio of the Expenses (in $) in Malaysia in 2004 to that in 2005?
Provide a succinct answer. 0.93. What is the ratio of the Expenses (in $) of Philippines in 2004 to that in 2005?
Provide a short and direct response. 0.93. What is the ratio of the Expenses (in $) in Dominican Republic in 2004 to that in 2006?
Offer a terse response. 0.72. What is the ratio of the Expenses (in $) of Greece in 2004 to that in 2006?
Your answer should be compact. 0.88. What is the ratio of the Expenses (in $) in Malaysia in 2004 to that in 2006?
Provide a short and direct response. 0.85. What is the ratio of the Expenses (in $) of Philippines in 2004 to that in 2006?
Your answer should be very brief. 0.86. What is the ratio of the Expenses (in $) in Dominican Republic in 2004 to that in 2007?
Provide a short and direct response. 0.63. What is the ratio of the Expenses (in $) in Greece in 2004 to that in 2007?
Keep it short and to the point. 0.78. What is the ratio of the Expenses (in $) of Malaysia in 2004 to that in 2007?
Offer a very short reply. 0.74. What is the ratio of the Expenses (in $) in Philippines in 2004 to that in 2007?
Ensure brevity in your answer.  0.79. What is the ratio of the Expenses (in $) in Dominican Republic in 2004 to that in 2008?
Ensure brevity in your answer.  0.49. What is the ratio of the Expenses (in $) of Greece in 2004 to that in 2008?
Your response must be concise. 0.71. What is the ratio of the Expenses (in $) in Malaysia in 2004 to that in 2008?
Your response must be concise. 0.59. What is the ratio of the Expenses (in $) of Philippines in 2004 to that in 2008?
Make the answer very short. 0.72. What is the ratio of the Expenses (in $) in Dominican Republic in 2004 to that in 2009?
Offer a terse response. 0.48. What is the ratio of the Expenses (in $) in Greece in 2004 to that in 2009?
Offer a very short reply. 0.66. What is the ratio of the Expenses (in $) of Malaysia in 2004 to that in 2009?
Offer a very short reply. 0.58. What is the ratio of the Expenses (in $) of Philippines in 2004 to that in 2009?
Offer a terse response. 0.64. What is the ratio of the Expenses (in $) in Dominican Republic in 2004 to that in 2010?
Make the answer very short. 0.44. What is the ratio of the Expenses (in $) of Greece in 2004 to that in 2010?
Offer a terse response. 0.71. What is the ratio of the Expenses (in $) of Malaysia in 2004 to that in 2010?
Give a very brief answer. 0.6. What is the ratio of the Expenses (in $) of Philippines in 2004 to that in 2010?
Keep it short and to the point. 0.6. What is the ratio of the Expenses (in $) in Dominican Republic in 2004 to that in 2011?
Offer a very short reply. 0.4. What is the ratio of the Expenses (in $) in Greece in 2004 to that in 2011?
Offer a terse response. 0.72. What is the ratio of the Expenses (in $) in Malaysia in 2004 to that in 2011?
Keep it short and to the point. 0.5. What is the ratio of the Expenses (in $) of Philippines in 2004 to that in 2011?
Provide a short and direct response. 0.59. What is the ratio of the Expenses (in $) in Dominican Republic in 2005 to that in 2006?
Your answer should be very brief. 0.85. What is the ratio of the Expenses (in $) in Greece in 2005 to that in 2006?
Your response must be concise. 0.92. What is the ratio of the Expenses (in $) in Malaysia in 2005 to that in 2006?
Make the answer very short. 0.91. What is the ratio of the Expenses (in $) in Philippines in 2005 to that in 2006?
Your answer should be very brief. 0.93. What is the ratio of the Expenses (in $) of Dominican Republic in 2005 to that in 2007?
Provide a short and direct response. 0.74. What is the ratio of the Expenses (in $) of Greece in 2005 to that in 2007?
Provide a succinct answer. 0.82. What is the ratio of the Expenses (in $) of Malaysia in 2005 to that in 2007?
Give a very brief answer. 0.8. What is the ratio of the Expenses (in $) in Philippines in 2005 to that in 2007?
Offer a very short reply. 0.85. What is the ratio of the Expenses (in $) in Dominican Republic in 2005 to that in 2008?
Your answer should be very brief. 0.58. What is the ratio of the Expenses (in $) in Greece in 2005 to that in 2008?
Offer a terse response. 0.74. What is the ratio of the Expenses (in $) in Malaysia in 2005 to that in 2008?
Your answer should be compact. 0.64. What is the ratio of the Expenses (in $) of Philippines in 2005 to that in 2008?
Ensure brevity in your answer.  0.77. What is the ratio of the Expenses (in $) in Dominican Republic in 2005 to that in 2009?
Your answer should be very brief. 0.56. What is the ratio of the Expenses (in $) in Greece in 2005 to that in 2009?
Provide a succinct answer. 0.68. What is the ratio of the Expenses (in $) in Malaysia in 2005 to that in 2009?
Make the answer very short. 0.62. What is the ratio of the Expenses (in $) of Philippines in 2005 to that in 2009?
Make the answer very short. 0.69. What is the ratio of the Expenses (in $) in Dominican Republic in 2005 to that in 2010?
Offer a terse response. 0.52. What is the ratio of the Expenses (in $) in Greece in 2005 to that in 2010?
Keep it short and to the point. 0.74. What is the ratio of the Expenses (in $) in Malaysia in 2005 to that in 2010?
Offer a very short reply. 0.64. What is the ratio of the Expenses (in $) in Philippines in 2005 to that in 2010?
Give a very brief answer. 0.64. What is the ratio of the Expenses (in $) in Dominican Republic in 2005 to that in 2011?
Ensure brevity in your answer.  0.48. What is the ratio of the Expenses (in $) in Greece in 2005 to that in 2011?
Keep it short and to the point. 0.75. What is the ratio of the Expenses (in $) in Malaysia in 2005 to that in 2011?
Provide a short and direct response. 0.53. What is the ratio of the Expenses (in $) in Philippines in 2005 to that in 2011?
Provide a short and direct response. 0.64. What is the ratio of the Expenses (in $) of Dominican Republic in 2006 to that in 2007?
Your response must be concise. 0.88. What is the ratio of the Expenses (in $) in Greece in 2006 to that in 2007?
Offer a very short reply. 0.89. What is the ratio of the Expenses (in $) of Malaysia in 2006 to that in 2007?
Your answer should be very brief. 0.88. What is the ratio of the Expenses (in $) of Philippines in 2006 to that in 2007?
Your answer should be very brief. 0.92. What is the ratio of the Expenses (in $) of Dominican Republic in 2006 to that in 2008?
Your response must be concise. 0.68. What is the ratio of the Expenses (in $) of Greece in 2006 to that in 2008?
Your answer should be very brief. 0.8. What is the ratio of the Expenses (in $) in Malaysia in 2006 to that in 2008?
Give a very brief answer. 0.7. What is the ratio of the Expenses (in $) in Philippines in 2006 to that in 2008?
Offer a terse response. 0.83. What is the ratio of the Expenses (in $) in Dominican Republic in 2006 to that in 2009?
Give a very brief answer. 0.66. What is the ratio of the Expenses (in $) of Greece in 2006 to that in 2009?
Your answer should be very brief. 0.74. What is the ratio of the Expenses (in $) in Malaysia in 2006 to that in 2009?
Your response must be concise. 0.68. What is the ratio of the Expenses (in $) in Philippines in 2006 to that in 2009?
Ensure brevity in your answer.  0.74. What is the ratio of the Expenses (in $) of Dominican Republic in 2006 to that in 2010?
Your answer should be very brief. 0.62. What is the ratio of the Expenses (in $) in Greece in 2006 to that in 2010?
Make the answer very short. 0.8. What is the ratio of the Expenses (in $) in Malaysia in 2006 to that in 2010?
Ensure brevity in your answer.  0.71. What is the ratio of the Expenses (in $) of Philippines in 2006 to that in 2010?
Provide a short and direct response. 0.69. What is the ratio of the Expenses (in $) of Dominican Republic in 2006 to that in 2011?
Your response must be concise. 0.56. What is the ratio of the Expenses (in $) in Greece in 2006 to that in 2011?
Provide a succinct answer. 0.82. What is the ratio of the Expenses (in $) of Malaysia in 2006 to that in 2011?
Make the answer very short. 0.59. What is the ratio of the Expenses (in $) in Philippines in 2006 to that in 2011?
Ensure brevity in your answer.  0.69. What is the ratio of the Expenses (in $) in Dominican Republic in 2007 to that in 2008?
Provide a succinct answer. 0.77. What is the ratio of the Expenses (in $) of Greece in 2007 to that in 2008?
Ensure brevity in your answer.  0.9. What is the ratio of the Expenses (in $) of Malaysia in 2007 to that in 2008?
Provide a succinct answer. 0.8. What is the ratio of the Expenses (in $) of Philippines in 2007 to that in 2008?
Provide a succinct answer. 0.9. What is the ratio of the Expenses (in $) of Dominican Republic in 2007 to that in 2009?
Ensure brevity in your answer.  0.76. What is the ratio of the Expenses (in $) in Greece in 2007 to that in 2009?
Ensure brevity in your answer.  0.84. What is the ratio of the Expenses (in $) of Malaysia in 2007 to that in 2009?
Your response must be concise. 0.78. What is the ratio of the Expenses (in $) in Philippines in 2007 to that in 2009?
Give a very brief answer. 0.8. What is the ratio of the Expenses (in $) of Dominican Republic in 2007 to that in 2010?
Your answer should be compact. 0.7. What is the ratio of the Expenses (in $) of Greece in 2007 to that in 2010?
Keep it short and to the point. 0.9. What is the ratio of the Expenses (in $) in Malaysia in 2007 to that in 2010?
Make the answer very short. 0.8. What is the ratio of the Expenses (in $) in Philippines in 2007 to that in 2010?
Give a very brief answer. 0.75. What is the ratio of the Expenses (in $) in Dominican Republic in 2007 to that in 2011?
Your response must be concise. 0.64. What is the ratio of the Expenses (in $) in Greece in 2007 to that in 2011?
Your answer should be very brief. 0.92. What is the ratio of the Expenses (in $) of Malaysia in 2007 to that in 2011?
Your response must be concise. 0.67. What is the ratio of the Expenses (in $) in Philippines in 2007 to that in 2011?
Provide a short and direct response. 0.75. What is the ratio of the Expenses (in $) in Dominican Republic in 2008 to that in 2009?
Your answer should be compact. 0.98. What is the ratio of the Expenses (in $) in Greece in 2008 to that in 2009?
Give a very brief answer. 0.93. What is the ratio of the Expenses (in $) of Malaysia in 2008 to that in 2009?
Ensure brevity in your answer.  0.98. What is the ratio of the Expenses (in $) in Philippines in 2008 to that in 2009?
Give a very brief answer. 0.89. What is the ratio of the Expenses (in $) of Dominican Republic in 2008 to that in 2010?
Offer a terse response. 0.91. What is the ratio of the Expenses (in $) in Malaysia in 2008 to that in 2010?
Your answer should be very brief. 1.01. What is the ratio of the Expenses (in $) of Philippines in 2008 to that in 2010?
Keep it short and to the point. 0.83. What is the ratio of the Expenses (in $) of Dominican Republic in 2008 to that in 2011?
Provide a short and direct response. 0.83. What is the ratio of the Expenses (in $) in Greece in 2008 to that in 2011?
Keep it short and to the point. 1.02. What is the ratio of the Expenses (in $) in Malaysia in 2008 to that in 2011?
Offer a very short reply. 0.84. What is the ratio of the Expenses (in $) of Philippines in 2008 to that in 2011?
Provide a succinct answer. 0.83. What is the ratio of the Expenses (in $) in Dominican Republic in 2009 to that in 2010?
Give a very brief answer. 0.93. What is the ratio of the Expenses (in $) of Greece in 2009 to that in 2010?
Make the answer very short. 1.08. What is the ratio of the Expenses (in $) of Malaysia in 2009 to that in 2010?
Offer a very short reply. 1.03. What is the ratio of the Expenses (in $) of Philippines in 2009 to that in 2010?
Your response must be concise. 0.94. What is the ratio of the Expenses (in $) in Dominican Republic in 2009 to that in 2011?
Your answer should be very brief. 0.85. What is the ratio of the Expenses (in $) in Greece in 2009 to that in 2011?
Ensure brevity in your answer.  1.1. What is the ratio of the Expenses (in $) in Malaysia in 2009 to that in 2011?
Your response must be concise. 0.86. What is the ratio of the Expenses (in $) of Philippines in 2009 to that in 2011?
Keep it short and to the point. 0.93. What is the ratio of the Expenses (in $) of Dominican Republic in 2010 to that in 2011?
Offer a terse response. 0.91. What is the ratio of the Expenses (in $) of Greece in 2010 to that in 2011?
Keep it short and to the point. 1.02. What is the ratio of the Expenses (in $) of Malaysia in 2010 to that in 2011?
Provide a succinct answer. 0.83. What is the ratio of the Expenses (in $) of Philippines in 2010 to that in 2011?
Your response must be concise. 0.99. What is the difference between the highest and the second highest Expenses (in $) of Dominican Republic?
Ensure brevity in your answer.  2.80e+1. What is the difference between the highest and the second highest Expenses (in $) of Greece?
Provide a succinct answer. 8.50e+09. What is the difference between the highest and the second highest Expenses (in $) of Malaysia?
Ensure brevity in your answer.  2.54e+1. What is the difference between the highest and the second highest Expenses (in $) of Philippines?
Offer a terse response. 1.12e+1. What is the difference between the highest and the lowest Expenses (in $) of Dominican Republic?
Give a very brief answer. 1.85e+11. What is the difference between the highest and the lowest Expenses (in $) in Greece?
Your answer should be very brief. 4.13e+1. What is the difference between the highest and the lowest Expenses (in $) of Malaysia?
Ensure brevity in your answer.  9.04e+1. What is the difference between the highest and the lowest Expenses (in $) of Philippines?
Give a very brief answer. 6.25e+11. 